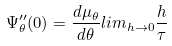Convert formula to latex. <formula><loc_0><loc_0><loc_500><loc_500>\Psi _ { \theta } ^ { \prime \prime } ( 0 ) = \frac { d \mu _ { \theta } } { d \theta } l i m _ { h \rightarrow 0 } \frac { h } { \tau }</formula> 